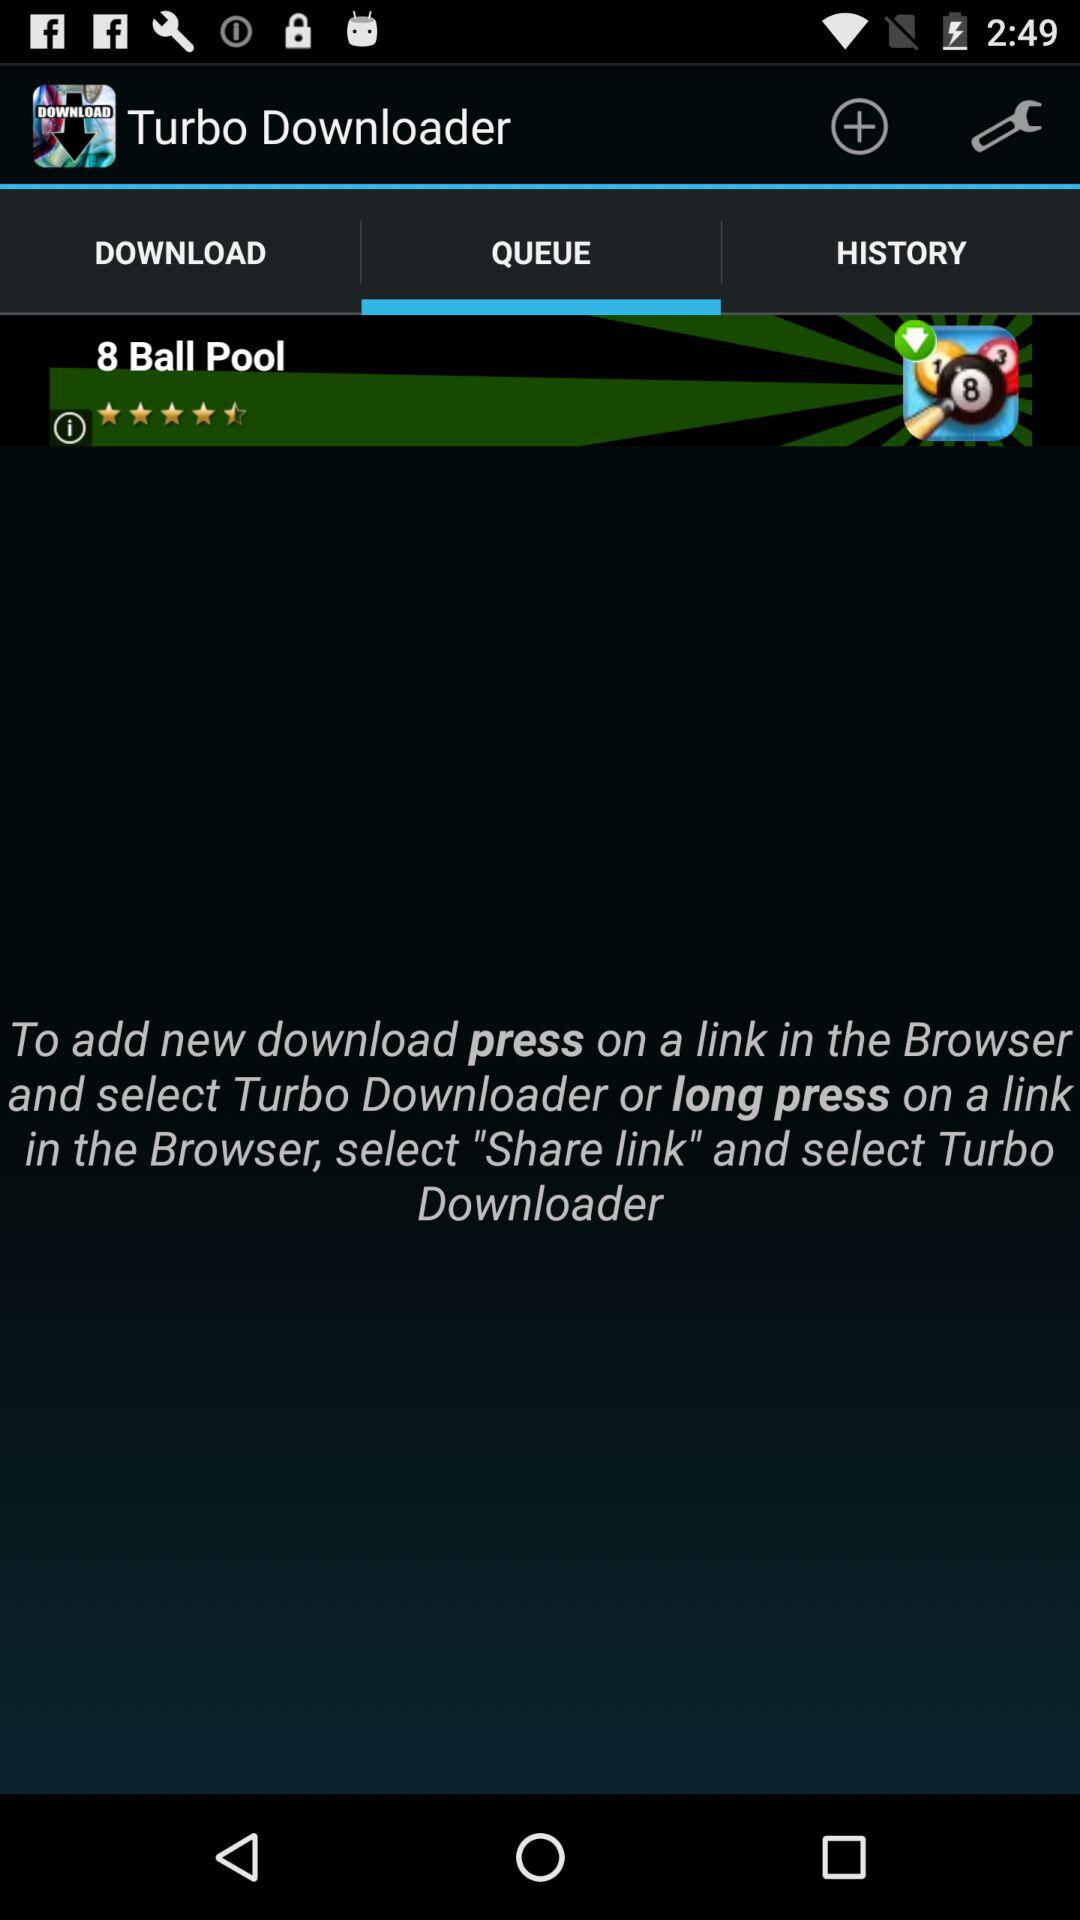What is the name of the application? The name of the application is "Turbo Downloader". 